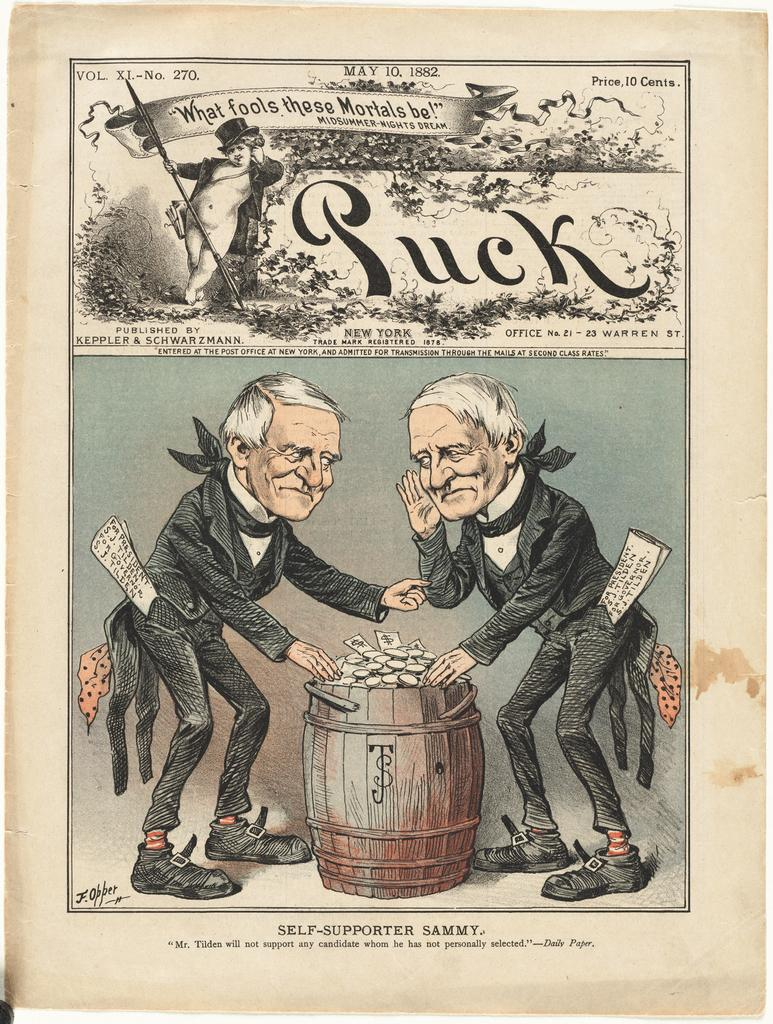<image>
Relay a brief, clear account of the picture shown. The old page from Puck magazine shows two old men hunched over a barrel of money 